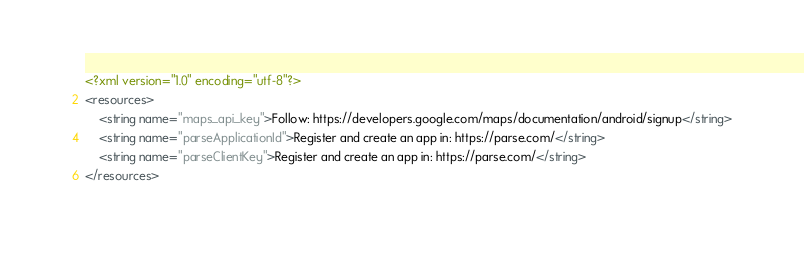Convert code to text. <code><loc_0><loc_0><loc_500><loc_500><_XML_><?xml version="1.0" encoding="utf-8"?>
<resources>
    <string name="maps_api_key">Follow: https://developers.google.com/maps/documentation/android/signup</string>
    <string name="parseApplicationId">Register and create an app in: https://parse.com/</string>
    <string name="parseClientKey">Register and create an app in: https://parse.com/</string>
</resources></code> 